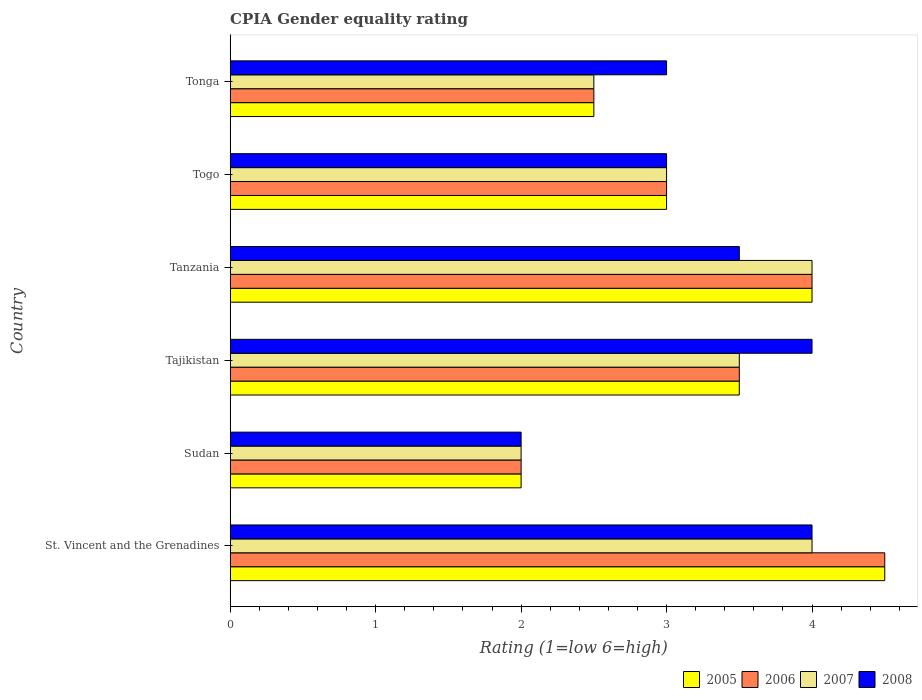Are the number of bars on each tick of the Y-axis equal?
Provide a short and direct response. Yes. How many bars are there on the 1st tick from the top?
Your answer should be compact. 4. How many bars are there on the 6th tick from the bottom?
Your response must be concise. 4. What is the label of the 5th group of bars from the top?
Keep it short and to the point. Sudan. What is the CPIA rating in 2006 in Tonga?
Provide a short and direct response. 2.5. Across all countries, what is the maximum CPIA rating in 2008?
Provide a short and direct response. 4. In which country was the CPIA rating in 2008 maximum?
Ensure brevity in your answer.  St. Vincent and the Grenadines. In which country was the CPIA rating in 2007 minimum?
Ensure brevity in your answer.  Sudan. What is the total CPIA rating in 2005 in the graph?
Give a very brief answer. 19.5. What is the difference between the CPIA rating in 2008 in Tanzania and the CPIA rating in 2005 in Tonga?
Provide a short and direct response. 1. What is the average CPIA rating in 2007 per country?
Your response must be concise. 3.17. What is the difference between the CPIA rating in 2006 and CPIA rating in 2007 in Tonga?
Give a very brief answer. 0. In how many countries, is the CPIA rating in 2006 greater than 0.2 ?
Give a very brief answer. 6. What is the ratio of the CPIA rating in 2008 in St. Vincent and the Grenadines to that in Togo?
Your answer should be compact. 1.33. Is the difference between the CPIA rating in 2006 in St. Vincent and the Grenadines and Sudan greater than the difference between the CPIA rating in 2007 in St. Vincent and the Grenadines and Sudan?
Make the answer very short. Yes. What is the difference between the highest and the second highest CPIA rating in 2005?
Offer a very short reply. 0.5. Is it the case that in every country, the sum of the CPIA rating in 2005 and CPIA rating in 2007 is greater than the sum of CPIA rating in 2008 and CPIA rating in 2006?
Your answer should be very brief. No. Is it the case that in every country, the sum of the CPIA rating in 2005 and CPIA rating in 2006 is greater than the CPIA rating in 2008?
Offer a terse response. Yes. How many bars are there?
Provide a short and direct response. 24. How many countries are there in the graph?
Your answer should be very brief. 6. What is the difference between two consecutive major ticks on the X-axis?
Make the answer very short. 1. Are the values on the major ticks of X-axis written in scientific E-notation?
Offer a terse response. No. Does the graph contain grids?
Keep it short and to the point. No. Where does the legend appear in the graph?
Ensure brevity in your answer.  Bottom right. How many legend labels are there?
Keep it short and to the point. 4. What is the title of the graph?
Your response must be concise. CPIA Gender equality rating. Does "1974" appear as one of the legend labels in the graph?
Ensure brevity in your answer.  No. What is the Rating (1=low 6=high) of 2007 in St. Vincent and the Grenadines?
Your response must be concise. 4. What is the Rating (1=low 6=high) in 2005 in Sudan?
Offer a terse response. 2. What is the Rating (1=low 6=high) of 2007 in Sudan?
Keep it short and to the point. 2. What is the Rating (1=low 6=high) in 2008 in Sudan?
Your answer should be compact. 2. What is the Rating (1=low 6=high) in 2005 in Tanzania?
Your answer should be compact. 4. What is the Rating (1=low 6=high) of 2007 in Tanzania?
Keep it short and to the point. 4. What is the Rating (1=low 6=high) in 2008 in Tanzania?
Provide a short and direct response. 3.5. What is the Rating (1=low 6=high) in 2006 in Togo?
Your response must be concise. 3. What is the Rating (1=low 6=high) in 2007 in Togo?
Ensure brevity in your answer.  3. What is the Rating (1=low 6=high) in 2008 in Togo?
Make the answer very short. 3. What is the Rating (1=low 6=high) in 2005 in Tonga?
Make the answer very short. 2.5. What is the Rating (1=low 6=high) in 2007 in Tonga?
Your answer should be compact. 2.5. Across all countries, what is the maximum Rating (1=low 6=high) in 2005?
Ensure brevity in your answer.  4.5. Across all countries, what is the maximum Rating (1=low 6=high) of 2007?
Give a very brief answer. 4. Across all countries, what is the minimum Rating (1=low 6=high) of 2005?
Your answer should be very brief. 2. Across all countries, what is the minimum Rating (1=low 6=high) of 2007?
Offer a terse response. 2. What is the difference between the Rating (1=low 6=high) in 2008 in St. Vincent and the Grenadines and that in Sudan?
Keep it short and to the point. 2. What is the difference between the Rating (1=low 6=high) in 2005 in St. Vincent and the Grenadines and that in Tajikistan?
Offer a very short reply. 1. What is the difference between the Rating (1=low 6=high) in 2007 in St. Vincent and the Grenadines and that in Tajikistan?
Provide a short and direct response. 0.5. What is the difference between the Rating (1=low 6=high) in 2008 in St. Vincent and the Grenadines and that in Tajikistan?
Provide a succinct answer. 0. What is the difference between the Rating (1=low 6=high) in 2007 in St. Vincent and the Grenadines and that in Tanzania?
Your answer should be compact. 0. What is the difference between the Rating (1=low 6=high) of 2008 in St. Vincent and the Grenadines and that in Tanzania?
Ensure brevity in your answer.  0.5. What is the difference between the Rating (1=low 6=high) of 2006 in St. Vincent and the Grenadines and that in Togo?
Provide a succinct answer. 1.5. What is the difference between the Rating (1=low 6=high) in 2007 in St. Vincent and the Grenadines and that in Togo?
Your answer should be very brief. 1. What is the difference between the Rating (1=low 6=high) in 2008 in St. Vincent and the Grenadines and that in Tonga?
Offer a very short reply. 1. What is the difference between the Rating (1=low 6=high) of 2007 in Sudan and that in Tajikistan?
Provide a short and direct response. -1.5. What is the difference between the Rating (1=low 6=high) of 2008 in Sudan and that in Tajikistan?
Your answer should be very brief. -2. What is the difference between the Rating (1=low 6=high) in 2005 in Sudan and that in Tanzania?
Make the answer very short. -2. What is the difference between the Rating (1=low 6=high) in 2006 in Sudan and that in Tanzania?
Your answer should be compact. -2. What is the difference between the Rating (1=low 6=high) of 2007 in Sudan and that in Tanzania?
Make the answer very short. -2. What is the difference between the Rating (1=low 6=high) in 2008 in Sudan and that in Tanzania?
Ensure brevity in your answer.  -1.5. What is the difference between the Rating (1=low 6=high) in 2006 in Sudan and that in Togo?
Offer a terse response. -1. What is the difference between the Rating (1=low 6=high) of 2006 in Sudan and that in Tonga?
Provide a short and direct response. -0.5. What is the difference between the Rating (1=low 6=high) of 2007 in Sudan and that in Tonga?
Your answer should be compact. -0.5. What is the difference between the Rating (1=low 6=high) of 2008 in Sudan and that in Tonga?
Give a very brief answer. -1. What is the difference between the Rating (1=low 6=high) of 2005 in Tajikistan and that in Tanzania?
Ensure brevity in your answer.  -0.5. What is the difference between the Rating (1=low 6=high) in 2006 in Tajikistan and that in Tanzania?
Give a very brief answer. -0.5. What is the difference between the Rating (1=low 6=high) of 2007 in Tajikistan and that in Tanzania?
Your answer should be compact. -0.5. What is the difference between the Rating (1=low 6=high) in 2005 in Tajikistan and that in Togo?
Your response must be concise. 0.5. What is the difference between the Rating (1=low 6=high) in 2007 in Tajikistan and that in Togo?
Provide a succinct answer. 0.5. What is the difference between the Rating (1=low 6=high) in 2008 in Tajikistan and that in Togo?
Offer a terse response. 1. What is the difference between the Rating (1=low 6=high) in 2006 in Tajikistan and that in Tonga?
Provide a short and direct response. 1. What is the difference between the Rating (1=low 6=high) of 2007 in Tajikistan and that in Tonga?
Your response must be concise. 1. What is the difference between the Rating (1=low 6=high) of 2006 in Tanzania and that in Togo?
Keep it short and to the point. 1. What is the difference between the Rating (1=low 6=high) of 2008 in Tanzania and that in Togo?
Make the answer very short. 0.5. What is the difference between the Rating (1=low 6=high) in 2005 in Tanzania and that in Tonga?
Make the answer very short. 1.5. What is the difference between the Rating (1=low 6=high) in 2006 in Tanzania and that in Tonga?
Ensure brevity in your answer.  1.5. What is the difference between the Rating (1=low 6=high) in 2007 in Tanzania and that in Tonga?
Your answer should be compact. 1.5. What is the difference between the Rating (1=low 6=high) in 2007 in Togo and that in Tonga?
Give a very brief answer. 0.5. What is the difference between the Rating (1=low 6=high) of 2008 in Togo and that in Tonga?
Offer a terse response. 0. What is the difference between the Rating (1=low 6=high) of 2005 in St. Vincent and the Grenadines and the Rating (1=low 6=high) of 2006 in Sudan?
Provide a succinct answer. 2.5. What is the difference between the Rating (1=low 6=high) in 2005 in St. Vincent and the Grenadines and the Rating (1=low 6=high) in 2007 in Sudan?
Keep it short and to the point. 2.5. What is the difference between the Rating (1=low 6=high) in 2005 in St. Vincent and the Grenadines and the Rating (1=low 6=high) in 2008 in Sudan?
Your answer should be very brief. 2.5. What is the difference between the Rating (1=low 6=high) in 2005 in St. Vincent and the Grenadines and the Rating (1=low 6=high) in 2008 in Tajikistan?
Provide a succinct answer. 0.5. What is the difference between the Rating (1=low 6=high) of 2006 in St. Vincent and the Grenadines and the Rating (1=low 6=high) of 2007 in Tajikistan?
Offer a terse response. 1. What is the difference between the Rating (1=low 6=high) of 2007 in St. Vincent and the Grenadines and the Rating (1=low 6=high) of 2008 in Tajikistan?
Provide a short and direct response. 0. What is the difference between the Rating (1=low 6=high) in 2005 in St. Vincent and the Grenadines and the Rating (1=low 6=high) in 2007 in Tanzania?
Give a very brief answer. 0.5. What is the difference between the Rating (1=low 6=high) of 2005 in St. Vincent and the Grenadines and the Rating (1=low 6=high) of 2008 in Tanzania?
Keep it short and to the point. 1. What is the difference between the Rating (1=low 6=high) in 2006 in St. Vincent and the Grenadines and the Rating (1=low 6=high) in 2008 in Tanzania?
Keep it short and to the point. 1. What is the difference between the Rating (1=low 6=high) of 2005 in St. Vincent and the Grenadines and the Rating (1=low 6=high) of 2007 in Togo?
Provide a short and direct response. 1.5. What is the difference between the Rating (1=low 6=high) in 2005 in St. Vincent and the Grenadines and the Rating (1=low 6=high) in 2008 in Togo?
Ensure brevity in your answer.  1.5. What is the difference between the Rating (1=low 6=high) of 2006 in St. Vincent and the Grenadines and the Rating (1=low 6=high) of 2007 in Togo?
Your answer should be very brief. 1.5. What is the difference between the Rating (1=low 6=high) in 2006 in St. Vincent and the Grenadines and the Rating (1=low 6=high) in 2008 in Togo?
Offer a very short reply. 1.5. What is the difference between the Rating (1=low 6=high) in 2007 in St. Vincent and the Grenadines and the Rating (1=low 6=high) in 2008 in Togo?
Your response must be concise. 1. What is the difference between the Rating (1=low 6=high) of 2005 in St. Vincent and the Grenadines and the Rating (1=low 6=high) of 2006 in Tonga?
Keep it short and to the point. 2. What is the difference between the Rating (1=low 6=high) of 2005 in St. Vincent and the Grenadines and the Rating (1=low 6=high) of 2008 in Tonga?
Provide a short and direct response. 1.5. What is the difference between the Rating (1=low 6=high) in 2005 in Sudan and the Rating (1=low 6=high) in 2006 in Tajikistan?
Provide a short and direct response. -1.5. What is the difference between the Rating (1=low 6=high) of 2005 in Sudan and the Rating (1=low 6=high) of 2008 in Tajikistan?
Your answer should be very brief. -2. What is the difference between the Rating (1=low 6=high) in 2005 in Sudan and the Rating (1=low 6=high) in 2006 in Tanzania?
Make the answer very short. -2. What is the difference between the Rating (1=low 6=high) of 2005 in Sudan and the Rating (1=low 6=high) of 2007 in Tanzania?
Keep it short and to the point. -2. What is the difference between the Rating (1=low 6=high) in 2005 in Sudan and the Rating (1=low 6=high) in 2008 in Tanzania?
Offer a terse response. -1.5. What is the difference between the Rating (1=low 6=high) in 2006 in Sudan and the Rating (1=low 6=high) in 2007 in Tanzania?
Give a very brief answer. -2. What is the difference between the Rating (1=low 6=high) in 2007 in Sudan and the Rating (1=low 6=high) in 2008 in Togo?
Your answer should be compact. -1. What is the difference between the Rating (1=low 6=high) of 2005 in Sudan and the Rating (1=low 6=high) of 2008 in Tonga?
Your answer should be compact. -1. What is the difference between the Rating (1=low 6=high) of 2006 in Sudan and the Rating (1=low 6=high) of 2007 in Tonga?
Give a very brief answer. -0.5. What is the difference between the Rating (1=low 6=high) of 2006 in Sudan and the Rating (1=low 6=high) of 2008 in Tonga?
Ensure brevity in your answer.  -1. What is the difference between the Rating (1=low 6=high) of 2007 in Sudan and the Rating (1=low 6=high) of 2008 in Tonga?
Make the answer very short. -1. What is the difference between the Rating (1=low 6=high) of 2005 in Tajikistan and the Rating (1=low 6=high) of 2006 in Tanzania?
Your answer should be compact. -0.5. What is the difference between the Rating (1=low 6=high) in 2005 in Tajikistan and the Rating (1=low 6=high) in 2007 in Tanzania?
Offer a very short reply. -0.5. What is the difference between the Rating (1=low 6=high) in 2005 in Tajikistan and the Rating (1=low 6=high) in 2008 in Tanzania?
Ensure brevity in your answer.  0. What is the difference between the Rating (1=low 6=high) of 2007 in Tajikistan and the Rating (1=low 6=high) of 2008 in Tanzania?
Provide a succinct answer. 0. What is the difference between the Rating (1=low 6=high) in 2005 in Tajikistan and the Rating (1=low 6=high) in 2006 in Togo?
Offer a terse response. 0.5. What is the difference between the Rating (1=low 6=high) of 2006 in Tajikistan and the Rating (1=low 6=high) of 2007 in Togo?
Your answer should be compact. 0.5. What is the difference between the Rating (1=low 6=high) of 2006 in Tajikistan and the Rating (1=low 6=high) of 2008 in Togo?
Make the answer very short. 0.5. What is the difference between the Rating (1=low 6=high) in 2005 in Tajikistan and the Rating (1=low 6=high) in 2006 in Tonga?
Offer a terse response. 1. What is the difference between the Rating (1=low 6=high) in 2005 in Tajikistan and the Rating (1=low 6=high) in 2008 in Tonga?
Provide a succinct answer. 0.5. What is the difference between the Rating (1=low 6=high) in 2006 in Tajikistan and the Rating (1=low 6=high) in 2007 in Tonga?
Offer a very short reply. 1. What is the difference between the Rating (1=low 6=high) in 2007 in Tajikistan and the Rating (1=low 6=high) in 2008 in Tonga?
Provide a succinct answer. 0.5. What is the difference between the Rating (1=low 6=high) of 2005 in Tanzania and the Rating (1=low 6=high) of 2008 in Togo?
Give a very brief answer. 1. What is the difference between the Rating (1=low 6=high) of 2006 in Tanzania and the Rating (1=low 6=high) of 2007 in Togo?
Keep it short and to the point. 1. What is the difference between the Rating (1=low 6=high) in 2007 in Tanzania and the Rating (1=low 6=high) in 2008 in Togo?
Offer a very short reply. 1. What is the difference between the Rating (1=low 6=high) of 2006 in Tanzania and the Rating (1=low 6=high) of 2007 in Tonga?
Offer a very short reply. 1.5. What is the difference between the Rating (1=low 6=high) in 2007 in Togo and the Rating (1=low 6=high) in 2008 in Tonga?
Provide a short and direct response. 0. What is the average Rating (1=low 6=high) in 2005 per country?
Your response must be concise. 3.25. What is the average Rating (1=low 6=high) in 2006 per country?
Your response must be concise. 3.25. What is the average Rating (1=low 6=high) of 2007 per country?
Offer a very short reply. 3.17. What is the average Rating (1=low 6=high) of 2008 per country?
Offer a very short reply. 3.25. What is the difference between the Rating (1=low 6=high) of 2005 and Rating (1=low 6=high) of 2006 in St. Vincent and the Grenadines?
Your response must be concise. 0. What is the difference between the Rating (1=low 6=high) in 2006 and Rating (1=low 6=high) in 2007 in St. Vincent and the Grenadines?
Provide a succinct answer. 0.5. What is the difference between the Rating (1=low 6=high) in 2005 and Rating (1=low 6=high) in 2006 in Sudan?
Your answer should be very brief. 0. What is the difference between the Rating (1=low 6=high) in 2006 and Rating (1=low 6=high) in 2007 in Sudan?
Provide a succinct answer. 0. What is the difference between the Rating (1=low 6=high) of 2006 and Rating (1=low 6=high) of 2008 in Sudan?
Make the answer very short. 0. What is the difference between the Rating (1=low 6=high) in 2005 and Rating (1=low 6=high) in 2008 in Tajikistan?
Provide a succinct answer. -0.5. What is the difference between the Rating (1=low 6=high) of 2006 and Rating (1=low 6=high) of 2008 in Tajikistan?
Give a very brief answer. -0.5. What is the difference between the Rating (1=low 6=high) of 2007 and Rating (1=low 6=high) of 2008 in Tajikistan?
Your answer should be very brief. -0.5. What is the difference between the Rating (1=low 6=high) of 2005 and Rating (1=low 6=high) of 2008 in Tanzania?
Offer a terse response. 0.5. What is the difference between the Rating (1=low 6=high) of 2006 and Rating (1=low 6=high) of 2007 in Tanzania?
Your response must be concise. 0. What is the difference between the Rating (1=low 6=high) of 2005 and Rating (1=low 6=high) of 2006 in Togo?
Your answer should be compact. 0. What is the difference between the Rating (1=low 6=high) of 2005 and Rating (1=low 6=high) of 2008 in Togo?
Offer a very short reply. 0. What is the difference between the Rating (1=low 6=high) of 2006 and Rating (1=low 6=high) of 2007 in Togo?
Provide a succinct answer. 0. What is the difference between the Rating (1=low 6=high) of 2006 and Rating (1=low 6=high) of 2008 in Togo?
Provide a succinct answer. 0. What is the difference between the Rating (1=low 6=high) in 2007 and Rating (1=low 6=high) in 2008 in Togo?
Offer a very short reply. 0. What is the difference between the Rating (1=low 6=high) in 2005 and Rating (1=low 6=high) in 2007 in Tonga?
Your answer should be compact. 0. What is the difference between the Rating (1=low 6=high) in 2005 and Rating (1=low 6=high) in 2008 in Tonga?
Your response must be concise. -0.5. What is the difference between the Rating (1=low 6=high) in 2006 and Rating (1=low 6=high) in 2007 in Tonga?
Your answer should be very brief. 0. What is the difference between the Rating (1=low 6=high) in 2006 and Rating (1=low 6=high) in 2008 in Tonga?
Provide a succinct answer. -0.5. What is the difference between the Rating (1=low 6=high) of 2007 and Rating (1=low 6=high) of 2008 in Tonga?
Provide a short and direct response. -0.5. What is the ratio of the Rating (1=low 6=high) of 2005 in St. Vincent and the Grenadines to that in Sudan?
Keep it short and to the point. 2.25. What is the ratio of the Rating (1=low 6=high) of 2006 in St. Vincent and the Grenadines to that in Sudan?
Give a very brief answer. 2.25. What is the ratio of the Rating (1=low 6=high) of 2005 in St. Vincent and the Grenadines to that in Tanzania?
Give a very brief answer. 1.12. What is the ratio of the Rating (1=low 6=high) in 2006 in St. Vincent and the Grenadines to that in Tanzania?
Provide a succinct answer. 1.12. What is the ratio of the Rating (1=low 6=high) in 2007 in St. Vincent and the Grenadines to that in Tanzania?
Your answer should be very brief. 1. What is the ratio of the Rating (1=low 6=high) of 2006 in St. Vincent and the Grenadines to that in Togo?
Give a very brief answer. 1.5. What is the ratio of the Rating (1=low 6=high) in 2008 in St. Vincent and the Grenadines to that in Togo?
Provide a succinct answer. 1.33. What is the ratio of the Rating (1=low 6=high) in 2006 in St. Vincent and the Grenadines to that in Tonga?
Keep it short and to the point. 1.8. What is the ratio of the Rating (1=low 6=high) in 2007 in St. Vincent and the Grenadines to that in Tonga?
Offer a terse response. 1.6. What is the ratio of the Rating (1=low 6=high) of 2005 in Sudan to that in Tajikistan?
Provide a short and direct response. 0.57. What is the ratio of the Rating (1=low 6=high) of 2006 in Sudan to that in Tajikistan?
Your response must be concise. 0.57. What is the ratio of the Rating (1=low 6=high) in 2007 in Sudan to that in Tajikistan?
Keep it short and to the point. 0.57. What is the ratio of the Rating (1=low 6=high) of 2005 in Sudan to that in Tanzania?
Your response must be concise. 0.5. What is the ratio of the Rating (1=low 6=high) in 2006 in Sudan to that in Tanzania?
Your answer should be compact. 0.5. What is the ratio of the Rating (1=low 6=high) in 2007 in Sudan to that in Tanzania?
Give a very brief answer. 0.5. What is the ratio of the Rating (1=low 6=high) in 2008 in Sudan to that in Togo?
Your response must be concise. 0.67. What is the ratio of the Rating (1=low 6=high) in 2005 in Sudan to that in Tonga?
Provide a short and direct response. 0.8. What is the ratio of the Rating (1=low 6=high) in 2006 in Sudan to that in Tonga?
Offer a very short reply. 0.8. What is the ratio of the Rating (1=low 6=high) in 2008 in Sudan to that in Tonga?
Your answer should be compact. 0.67. What is the ratio of the Rating (1=low 6=high) of 2008 in Tajikistan to that in Tanzania?
Your answer should be compact. 1.14. What is the ratio of the Rating (1=low 6=high) of 2005 in Tajikistan to that in Togo?
Offer a terse response. 1.17. What is the ratio of the Rating (1=low 6=high) of 2006 in Tajikistan to that in Togo?
Make the answer very short. 1.17. What is the ratio of the Rating (1=low 6=high) in 2007 in Tajikistan to that in Tonga?
Keep it short and to the point. 1.4. What is the ratio of the Rating (1=low 6=high) in 2005 in Tanzania to that in Togo?
Offer a terse response. 1.33. What is the ratio of the Rating (1=low 6=high) in 2007 in Tanzania to that in Togo?
Your answer should be very brief. 1.33. What is the ratio of the Rating (1=low 6=high) of 2008 in Tanzania to that in Togo?
Keep it short and to the point. 1.17. What is the ratio of the Rating (1=low 6=high) in 2007 in Tanzania to that in Tonga?
Ensure brevity in your answer.  1.6. What is the ratio of the Rating (1=low 6=high) of 2008 in Tanzania to that in Tonga?
Provide a short and direct response. 1.17. What is the ratio of the Rating (1=low 6=high) in 2006 in Togo to that in Tonga?
Offer a very short reply. 1.2. What is the ratio of the Rating (1=low 6=high) in 2008 in Togo to that in Tonga?
Your response must be concise. 1. What is the difference between the highest and the second highest Rating (1=low 6=high) in 2005?
Offer a terse response. 0.5. What is the difference between the highest and the second highest Rating (1=low 6=high) of 2006?
Keep it short and to the point. 0.5. What is the difference between the highest and the second highest Rating (1=low 6=high) in 2007?
Your answer should be compact. 0. What is the difference between the highest and the second highest Rating (1=low 6=high) of 2008?
Provide a succinct answer. 0. What is the difference between the highest and the lowest Rating (1=low 6=high) in 2005?
Ensure brevity in your answer.  2.5. What is the difference between the highest and the lowest Rating (1=low 6=high) in 2008?
Make the answer very short. 2. 